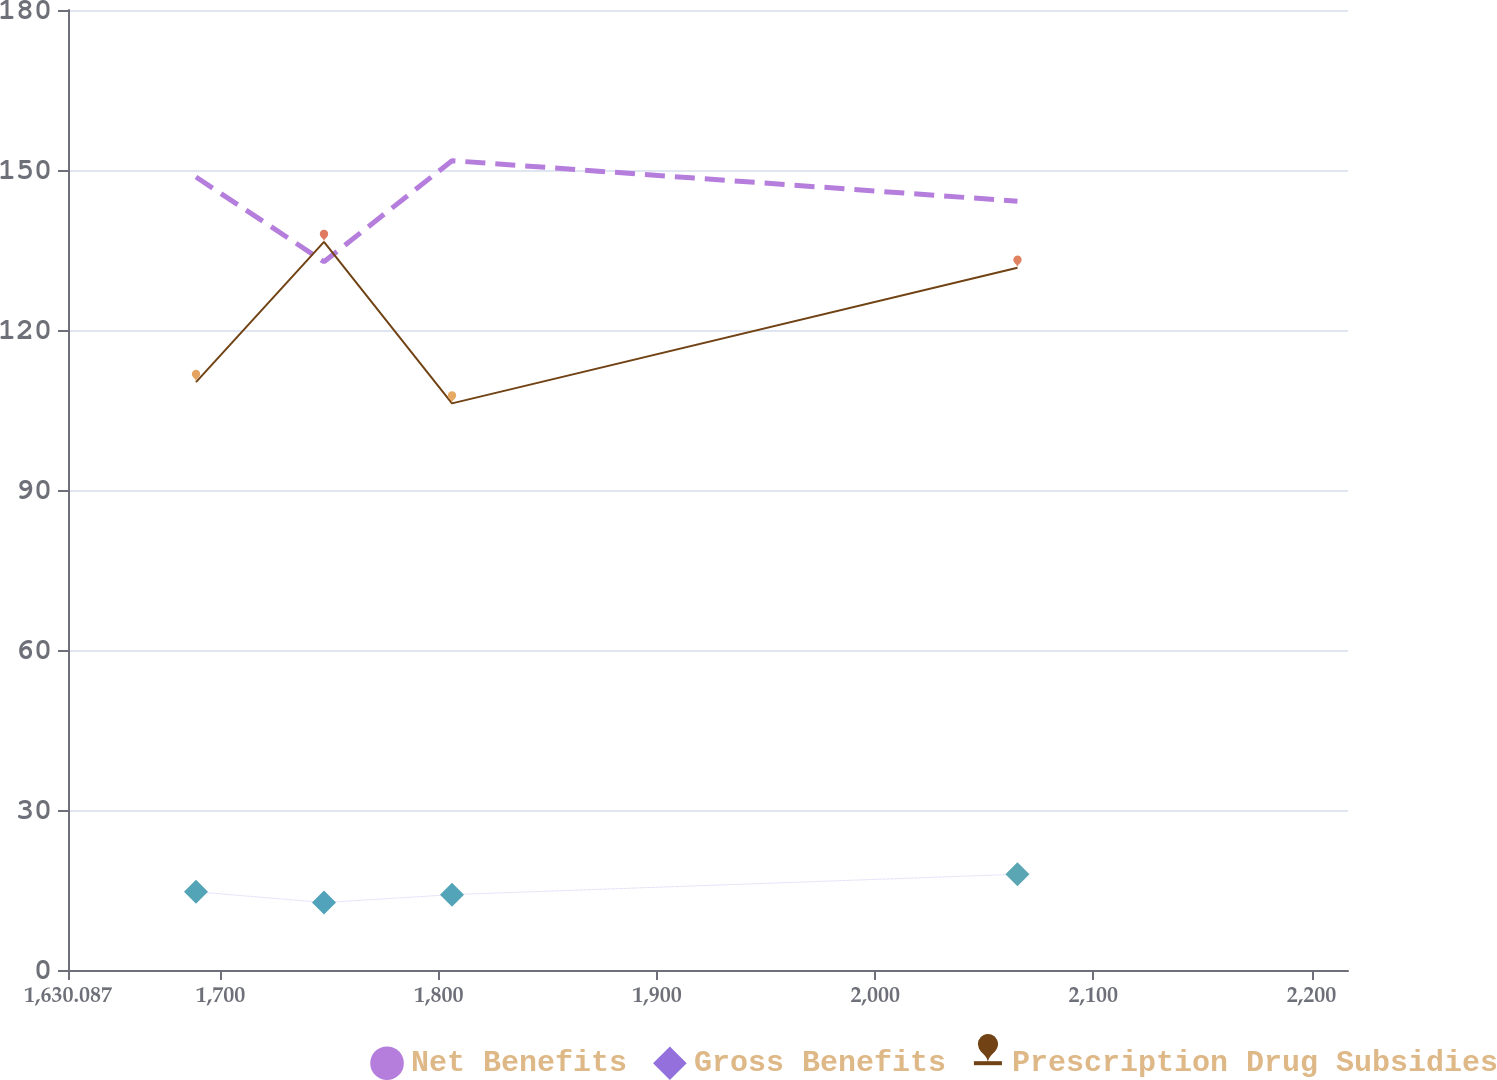Convert chart. <chart><loc_0><loc_0><loc_500><loc_500><line_chart><ecel><fcel>Net Benefits<fcel>Gross Benefits<fcel>Prescription Drug Subsidies<nl><fcel>1688.75<fcel>148.68<fcel>14.66<fcel>110.24<nl><fcel>1747.41<fcel>132.8<fcel>12.65<fcel>136.52<nl><fcel>1806.07<fcel>151.75<fcel>14.13<fcel>106.24<nl><fcel>2065.23<fcel>144.15<fcel>17.95<fcel>131.66<nl><fcel>2275.38<fcel>163.46<fcel>16.53<fcel>146.22<nl></chart> 